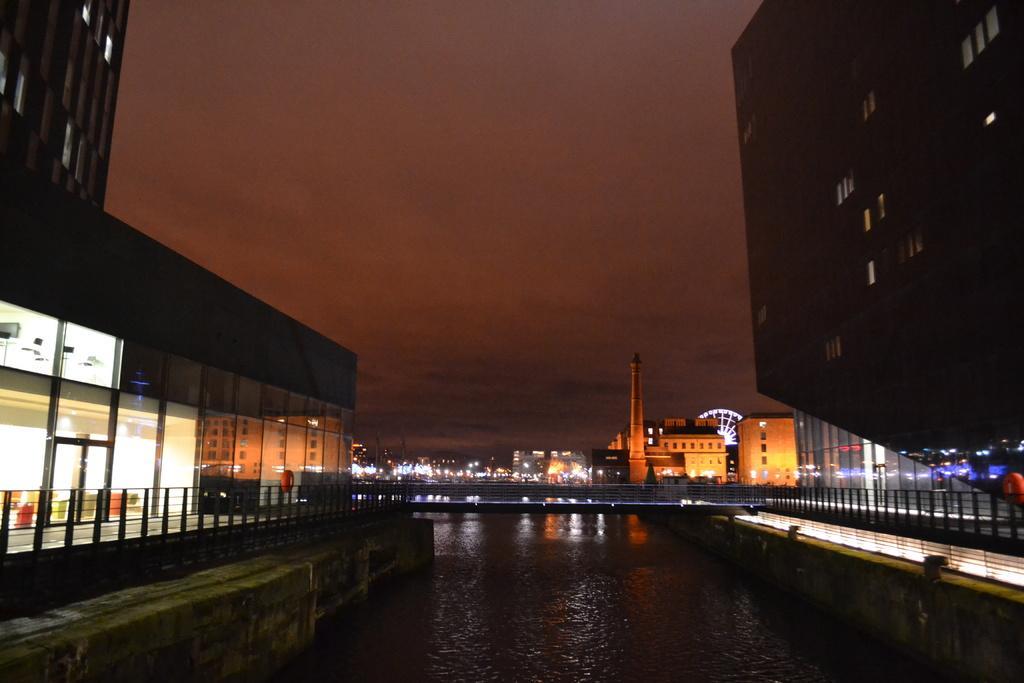Could you give a brief overview of what you see in this image? In this picture we can see few buildings, metal rods, lights and water, in the background we can find a giant wheel and a tower. 